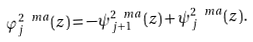<formula> <loc_0><loc_0><loc_500><loc_500>\varphi _ { j } ^ { 2 \ m a } ( z ) = - \psi _ { j + 1 } ^ { 2 \ m a } ( z ) + \psi _ { j } ^ { 2 \ m a } ( z ) .</formula> 